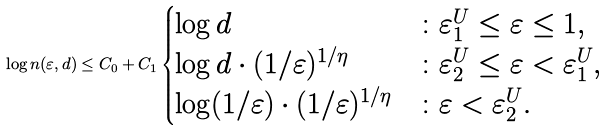<formula> <loc_0><loc_0><loc_500><loc_500>\log n ( \varepsilon , d ) \leq C _ { 0 } + C _ { 1 } \begin{cases} \log d & \colon \varepsilon _ { 1 } ^ { U } \leq \varepsilon \leq 1 , \\ \log d \cdot ( 1 / \varepsilon ) ^ { 1 / \eta } & \colon \varepsilon _ { 2 } ^ { U } \leq \varepsilon < \varepsilon _ { 1 } ^ { U } , \\ \log ( 1 / \varepsilon ) \cdot ( 1 / \varepsilon ) ^ { 1 / \eta } & \colon \varepsilon < \varepsilon _ { 2 } ^ { U } . \end{cases}</formula> 